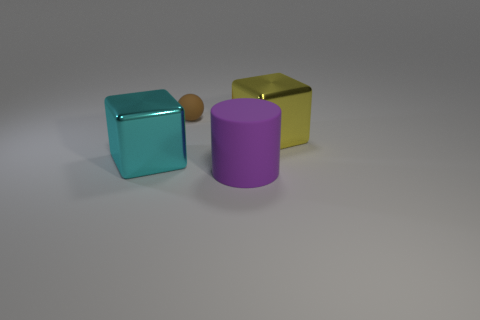Add 3 green spheres. How many objects exist? 7 Subtract all balls. How many objects are left? 3 Subtract all yellow blocks. How many blocks are left? 1 Subtract all purple spheres. Subtract all gray cylinders. How many spheres are left? 1 Subtract all gray cylinders. How many yellow blocks are left? 1 Subtract all big metallic cubes. Subtract all large gray metal objects. How many objects are left? 2 Add 2 small brown objects. How many small brown objects are left? 3 Add 4 green objects. How many green objects exist? 4 Subtract 0 purple cubes. How many objects are left? 4 